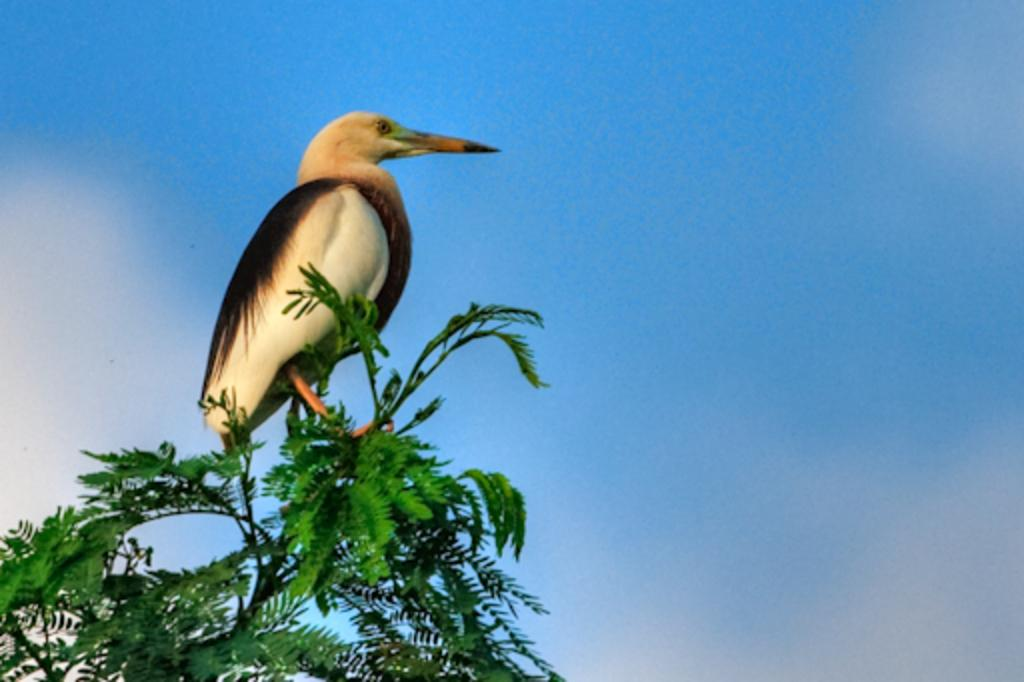What type of plant is depicted in the image? The image shows a plant with leaves and a stem. Is there any animal present in the image? Yes, there is a bird sitting on the plant. What can be seen in the background of the image? The sky is visible in the background of the image. What type of pie is being served on the boat in the image? There is no pie or boat present in the image; it features a plant with a bird sitting on it and a visible sky in the background. 